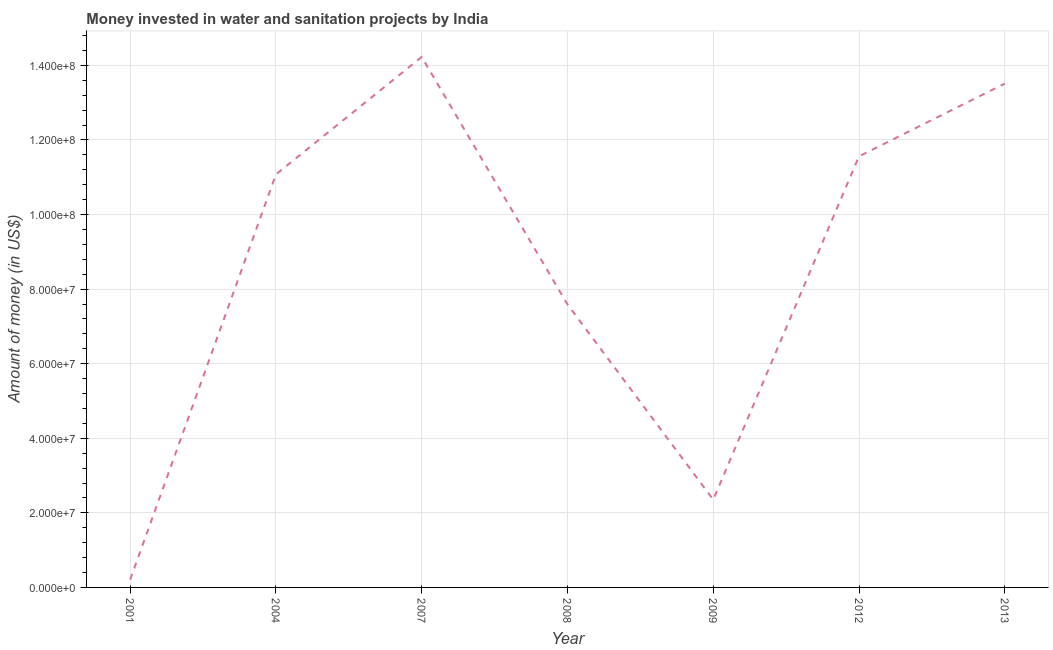What is the investment in 2009?
Provide a succinct answer. 2.35e+07. Across all years, what is the maximum investment?
Offer a very short reply. 1.42e+08. Across all years, what is the minimum investment?
Your answer should be very brief. 2.10e+06. In which year was the investment maximum?
Ensure brevity in your answer.  2007. In which year was the investment minimum?
Your response must be concise. 2001. What is the sum of the investment?
Give a very brief answer. 6.05e+08. What is the difference between the investment in 2008 and 2013?
Provide a short and direct response. -5.92e+07. What is the average investment per year?
Offer a very short reply. 8.65e+07. What is the median investment?
Make the answer very short. 1.11e+08. Do a majority of the years between 2009 and 2008 (inclusive) have investment greater than 84000000 US$?
Provide a short and direct response. No. What is the ratio of the investment in 2007 to that in 2009?
Offer a terse response. 6.05. Is the investment in 2001 less than that in 2012?
Offer a terse response. Yes. Is the difference between the investment in 2007 and 2013 greater than the difference between any two years?
Offer a very short reply. No. What is the difference between the highest and the second highest investment?
Your answer should be compact. 7.15e+06. What is the difference between the highest and the lowest investment?
Your response must be concise. 1.40e+08. Does the investment monotonically increase over the years?
Keep it short and to the point. No. How many years are there in the graph?
Keep it short and to the point. 7. What is the difference between two consecutive major ticks on the Y-axis?
Offer a terse response. 2.00e+07. Are the values on the major ticks of Y-axis written in scientific E-notation?
Ensure brevity in your answer.  Yes. What is the title of the graph?
Your answer should be very brief. Money invested in water and sanitation projects by India. What is the label or title of the Y-axis?
Provide a short and direct response. Amount of money (in US$). What is the Amount of money (in US$) in 2001?
Ensure brevity in your answer.  2.10e+06. What is the Amount of money (in US$) of 2004?
Give a very brief answer. 1.11e+08. What is the Amount of money (in US$) in 2007?
Provide a succinct answer. 1.42e+08. What is the Amount of money (in US$) in 2008?
Make the answer very short. 7.59e+07. What is the Amount of money (in US$) of 2009?
Give a very brief answer. 2.35e+07. What is the Amount of money (in US$) in 2012?
Provide a short and direct response. 1.16e+08. What is the Amount of money (in US$) in 2013?
Your answer should be very brief. 1.35e+08. What is the difference between the Amount of money (in US$) in 2001 and 2004?
Provide a succinct answer. -1.09e+08. What is the difference between the Amount of money (in US$) in 2001 and 2007?
Your answer should be compact. -1.40e+08. What is the difference between the Amount of money (in US$) in 2001 and 2008?
Keep it short and to the point. -7.38e+07. What is the difference between the Amount of money (in US$) in 2001 and 2009?
Make the answer very short. -2.14e+07. What is the difference between the Amount of money (in US$) in 2001 and 2012?
Offer a terse response. -1.14e+08. What is the difference between the Amount of money (in US$) in 2001 and 2013?
Your answer should be compact. -1.33e+08. What is the difference between the Amount of money (in US$) in 2004 and 2007?
Provide a succinct answer. -3.15e+07. What is the difference between the Amount of money (in US$) in 2004 and 2008?
Make the answer very short. 3.48e+07. What is the difference between the Amount of money (in US$) in 2004 and 2009?
Provide a succinct answer. 8.72e+07. What is the difference between the Amount of money (in US$) in 2004 and 2012?
Keep it short and to the point. -4.85e+06. What is the difference between the Amount of money (in US$) in 2004 and 2013?
Provide a succinct answer. -2.44e+07. What is the difference between the Amount of money (in US$) in 2007 and 2008?
Keep it short and to the point. 6.64e+07. What is the difference between the Amount of money (in US$) in 2007 and 2009?
Keep it short and to the point. 1.19e+08. What is the difference between the Amount of money (in US$) in 2007 and 2012?
Provide a short and direct response. 2.66e+07. What is the difference between the Amount of money (in US$) in 2007 and 2013?
Ensure brevity in your answer.  7.15e+06. What is the difference between the Amount of money (in US$) in 2008 and 2009?
Your answer should be compact. 5.24e+07. What is the difference between the Amount of money (in US$) in 2008 and 2012?
Make the answer very short. -3.97e+07. What is the difference between the Amount of money (in US$) in 2008 and 2013?
Keep it short and to the point. -5.92e+07. What is the difference between the Amount of money (in US$) in 2009 and 2012?
Offer a very short reply. -9.21e+07. What is the difference between the Amount of money (in US$) in 2009 and 2013?
Provide a succinct answer. -1.12e+08. What is the difference between the Amount of money (in US$) in 2012 and 2013?
Make the answer very short. -1.95e+07. What is the ratio of the Amount of money (in US$) in 2001 to that in 2004?
Keep it short and to the point. 0.02. What is the ratio of the Amount of money (in US$) in 2001 to that in 2007?
Your response must be concise. 0.01. What is the ratio of the Amount of money (in US$) in 2001 to that in 2008?
Provide a succinct answer. 0.03. What is the ratio of the Amount of money (in US$) in 2001 to that in 2009?
Keep it short and to the point. 0.09. What is the ratio of the Amount of money (in US$) in 2001 to that in 2012?
Provide a short and direct response. 0.02. What is the ratio of the Amount of money (in US$) in 2001 to that in 2013?
Keep it short and to the point. 0.02. What is the ratio of the Amount of money (in US$) in 2004 to that in 2007?
Ensure brevity in your answer.  0.78. What is the ratio of the Amount of money (in US$) in 2004 to that in 2008?
Ensure brevity in your answer.  1.46. What is the ratio of the Amount of money (in US$) in 2004 to that in 2009?
Give a very brief answer. 4.71. What is the ratio of the Amount of money (in US$) in 2004 to that in 2012?
Keep it short and to the point. 0.96. What is the ratio of the Amount of money (in US$) in 2004 to that in 2013?
Give a very brief answer. 0.82. What is the ratio of the Amount of money (in US$) in 2007 to that in 2008?
Offer a very short reply. 1.87. What is the ratio of the Amount of money (in US$) in 2007 to that in 2009?
Your answer should be very brief. 6.04. What is the ratio of the Amount of money (in US$) in 2007 to that in 2012?
Ensure brevity in your answer.  1.23. What is the ratio of the Amount of money (in US$) in 2007 to that in 2013?
Make the answer very short. 1.05. What is the ratio of the Amount of money (in US$) in 2008 to that in 2009?
Provide a succinct answer. 3.23. What is the ratio of the Amount of money (in US$) in 2008 to that in 2012?
Make the answer very short. 0.66. What is the ratio of the Amount of money (in US$) in 2008 to that in 2013?
Ensure brevity in your answer.  0.56. What is the ratio of the Amount of money (in US$) in 2009 to that in 2012?
Make the answer very short. 0.2. What is the ratio of the Amount of money (in US$) in 2009 to that in 2013?
Ensure brevity in your answer.  0.17. What is the ratio of the Amount of money (in US$) in 2012 to that in 2013?
Keep it short and to the point. 0.86. 